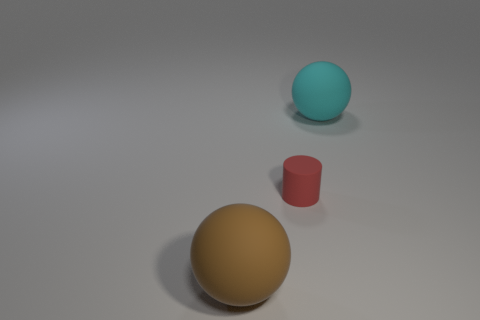What material is the other object that is the same size as the cyan rubber object?
Your response must be concise. Rubber. How many other things are there of the same material as the large brown object?
Provide a short and direct response. 2. Does the large brown sphere in front of the red rubber cylinder have the same material as the big cyan object?
Offer a very short reply. Yes. Are there more brown objects left of the tiny red rubber cylinder than brown matte balls left of the big brown sphere?
Make the answer very short. Yes. How many objects are big spheres left of the cyan object or red things?
Your response must be concise. 2. What is the shape of the cyan thing that is made of the same material as the small red cylinder?
Your answer should be very brief. Sphere. Are there any other things that have the same shape as the red matte thing?
Make the answer very short. No. There is a thing that is behind the big brown object and on the left side of the large cyan thing; what is its color?
Offer a very short reply. Red. What number of balls are big objects or small blue objects?
Give a very brief answer. 2. How many brown rubber balls have the same size as the rubber cylinder?
Provide a short and direct response. 0. 